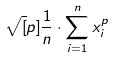<formula> <loc_0><loc_0><loc_500><loc_500>\sqrt { [ } p ] { \frac { 1 } { n } \cdot \sum _ { i = 1 } ^ { n } x _ { i } ^ { p } }</formula> 